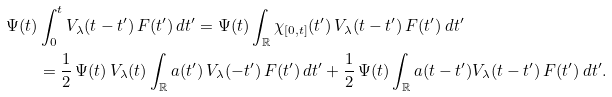<formula> <loc_0><loc_0><loc_500><loc_500>\Psi ( t ) & \int _ { 0 } ^ { t } V _ { \lambda } ( t - t ^ { \prime } ) \, F ( t ^ { \prime } ) \, d t ^ { \prime } = \Psi ( t ) \int _ { \mathbb { R } } \chi _ { [ 0 , t ] } ( t ^ { \prime } ) \, V _ { \lambda } ( t - t ^ { \prime } ) \, F ( t ^ { \prime } ) \, d t ^ { \prime } \\ & = \frac { 1 } { 2 } \, \Psi ( t ) \, V _ { \lambda } ( t ) \int _ { \mathbb { R } } a ( t ^ { \prime } ) \, V _ { \lambda } ( - t ^ { \prime } ) \, F ( t ^ { \prime } ) \, d t ^ { \prime } + \frac { 1 } { 2 } \, \Psi ( t ) \int _ { \mathbb { R } } a ( t - t ^ { \prime } ) V _ { \lambda } ( t - t ^ { \prime } ) \, F ( t ^ { \prime } ) \, d t ^ { \prime } .</formula> 